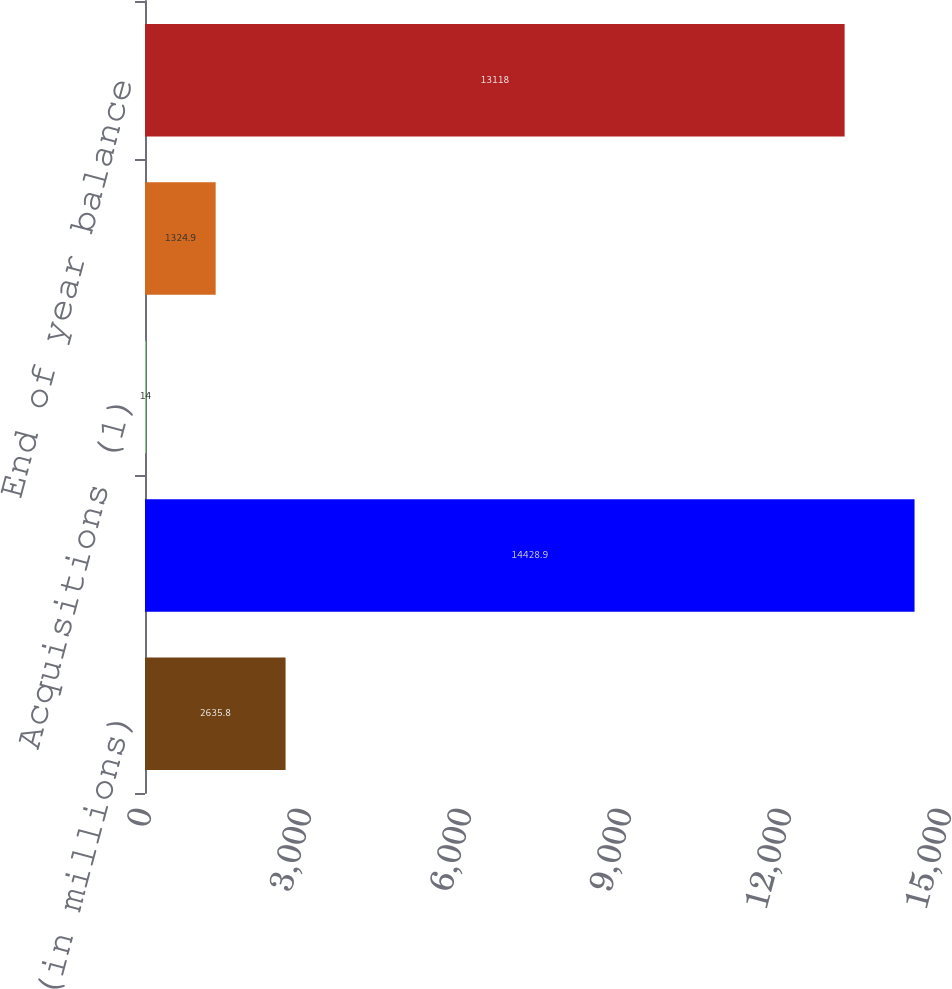Convert chart to OTSL. <chart><loc_0><loc_0><loc_500><loc_500><bar_chart><fcel>(in millions)<fcel>Beginning of year balance<fcel>Acquisitions (1)<fcel>Goodwill adjustments related<fcel>End of year balance<nl><fcel>2635.8<fcel>14428.9<fcel>14<fcel>1324.9<fcel>13118<nl></chart> 